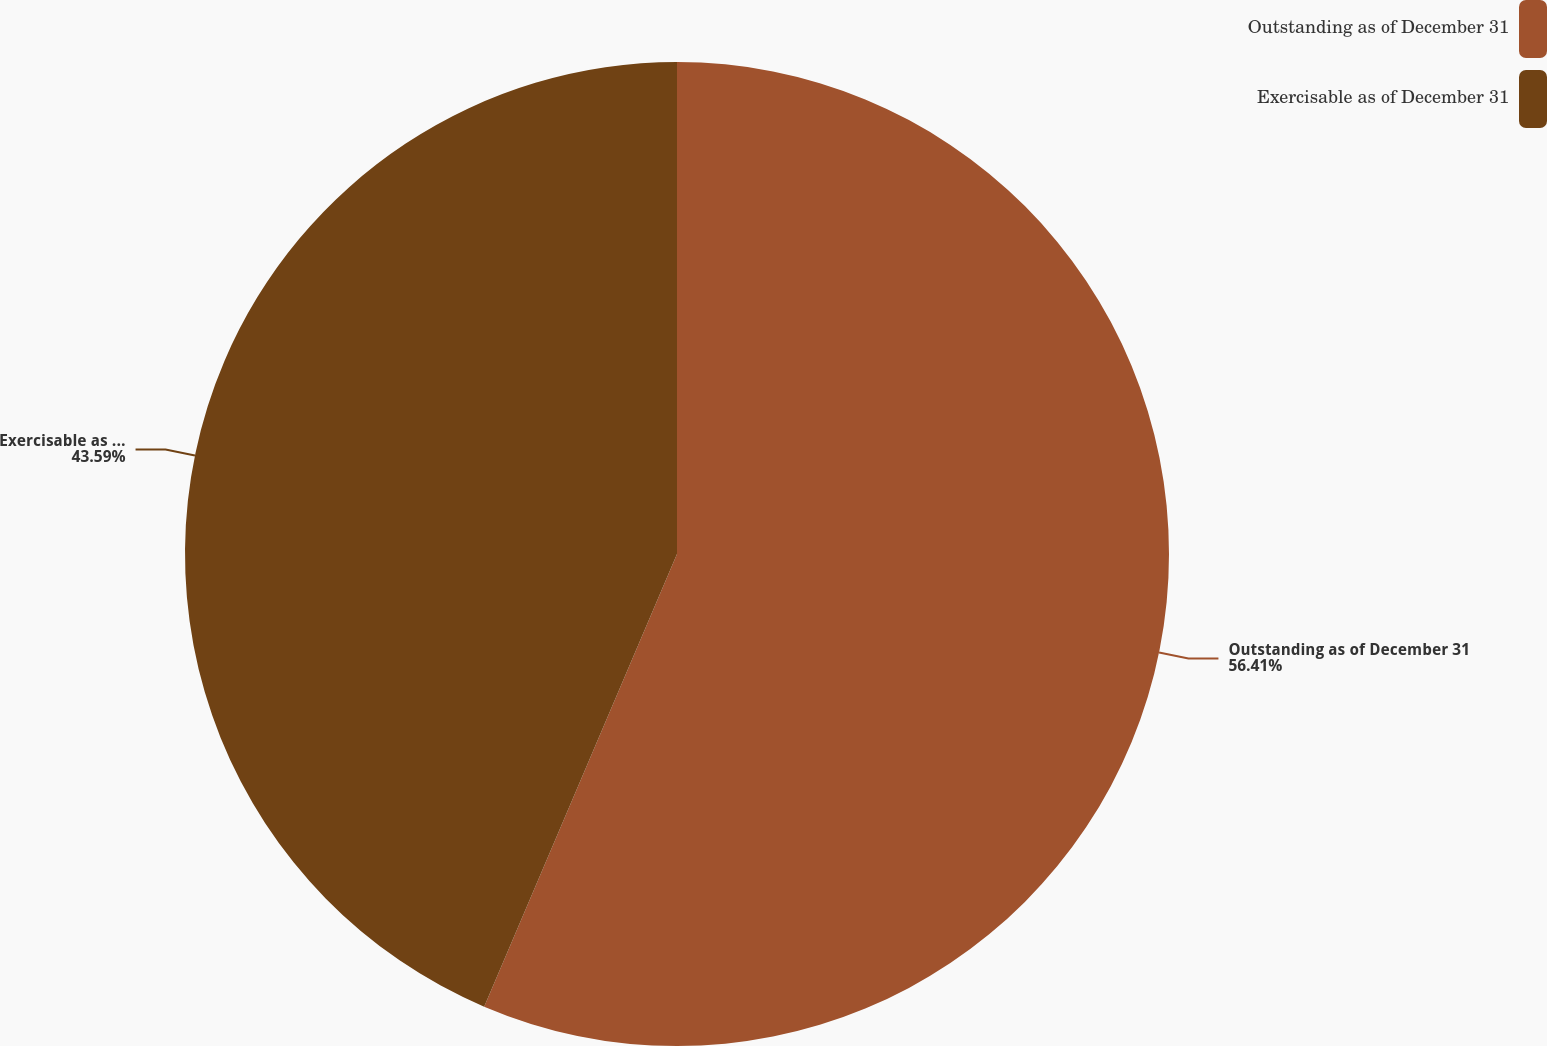<chart> <loc_0><loc_0><loc_500><loc_500><pie_chart><fcel>Outstanding as of December 31<fcel>Exercisable as of December 31<nl><fcel>56.41%<fcel>43.59%<nl></chart> 